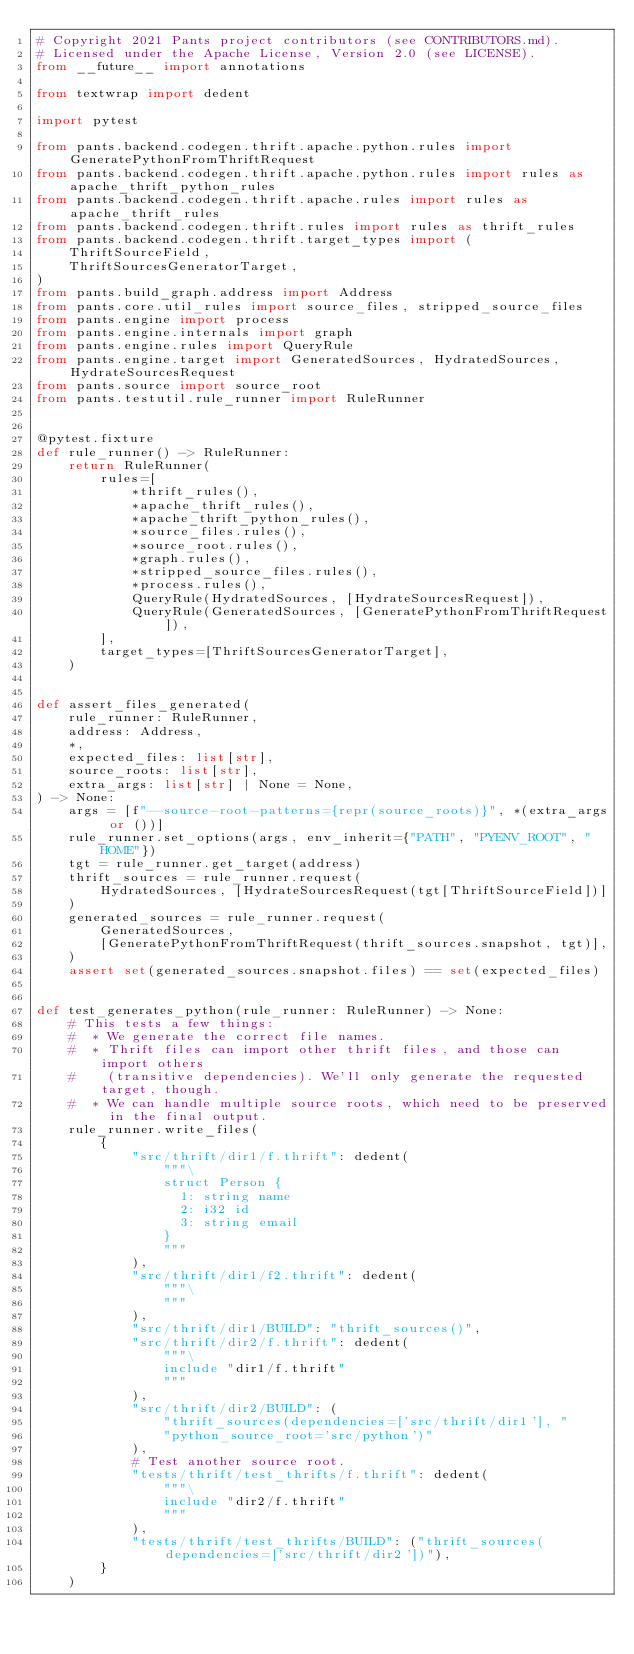<code> <loc_0><loc_0><loc_500><loc_500><_Python_># Copyright 2021 Pants project contributors (see CONTRIBUTORS.md).
# Licensed under the Apache License, Version 2.0 (see LICENSE).
from __future__ import annotations

from textwrap import dedent

import pytest

from pants.backend.codegen.thrift.apache.python.rules import GeneratePythonFromThriftRequest
from pants.backend.codegen.thrift.apache.python.rules import rules as apache_thrift_python_rules
from pants.backend.codegen.thrift.apache.rules import rules as apache_thrift_rules
from pants.backend.codegen.thrift.rules import rules as thrift_rules
from pants.backend.codegen.thrift.target_types import (
    ThriftSourceField,
    ThriftSourcesGeneratorTarget,
)
from pants.build_graph.address import Address
from pants.core.util_rules import source_files, stripped_source_files
from pants.engine import process
from pants.engine.internals import graph
from pants.engine.rules import QueryRule
from pants.engine.target import GeneratedSources, HydratedSources, HydrateSourcesRequest
from pants.source import source_root
from pants.testutil.rule_runner import RuleRunner


@pytest.fixture
def rule_runner() -> RuleRunner:
    return RuleRunner(
        rules=[
            *thrift_rules(),
            *apache_thrift_rules(),
            *apache_thrift_python_rules(),
            *source_files.rules(),
            *source_root.rules(),
            *graph.rules(),
            *stripped_source_files.rules(),
            *process.rules(),
            QueryRule(HydratedSources, [HydrateSourcesRequest]),
            QueryRule(GeneratedSources, [GeneratePythonFromThriftRequest]),
        ],
        target_types=[ThriftSourcesGeneratorTarget],
    )


def assert_files_generated(
    rule_runner: RuleRunner,
    address: Address,
    *,
    expected_files: list[str],
    source_roots: list[str],
    extra_args: list[str] | None = None,
) -> None:
    args = [f"--source-root-patterns={repr(source_roots)}", *(extra_args or ())]
    rule_runner.set_options(args, env_inherit={"PATH", "PYENV_ROOT", "HOME"})
    tgt = rule_runner.get_target(address)
    thrift_sources = rule_runner.request(
        HydratedSources, [HydrateSourcesRequest(tgt[ThriftSourceField])]
    )
    generated_sources = rule_runner.request(
        GeneratedSources,
        [GeneratePythonFromThriftRequest(thrift_sources.snapshot, tgt)],
    )
    assert set(generated_sources.snapshot.files) == set(expected_files)


def test_generates_python(rule_runner: RuleRunner) -> None:
    # This tests a few things:
    #  * We generate the correct file names.
    #  * Thrift files can import other thrift files, and those can import others
    #    (transitive dependencies). We'll only generate the requested target, though.
    #  * We can handle multiple source roots, which need to be preserved in the final output.
    rule_runner.write_files(
        {
            "src/thrift/dir1/f.thrift": dedent(
                """\
                struct Person {
                  1: string name
                  2: i32 id
                  3: string email
                }
                """
            ),
            "src/thrift/dir1/f2.thrift": dedent(
                """\
                """
            ),
            "src/thrift/dir1/BUILD": "thrift_sources()",
            "src/thrift/dir2/f.thrift": dedent(
                """\
                include "dir1/f.thrift"
                """
            ),
            "src/thrift/dir2/BUILD": (
                "thrift_sources(dependencies=['src/thrift/dir1'], "
                "python_source_root='src/python')"
            ),
            # Test another source root.
            "tests/thrift/test_thrifts/f.thrift": dedent(
                """\
                include "dir2/f.thrift"
                """
            ),
            "tests/thrift/test_thrifts/BUILD": ("thrift_sources(dependencies=['src/thrift/dir2'])"),
        }
    )
</code> 